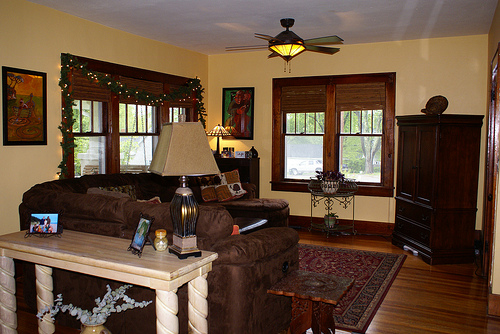Please provide the bounding box coordinate of the region this sentence describes: the rug is on the floor. Coordinates: [0.75, 0.71, 0.8, 0.77]. The location of the Persian-style rug on the floor. 